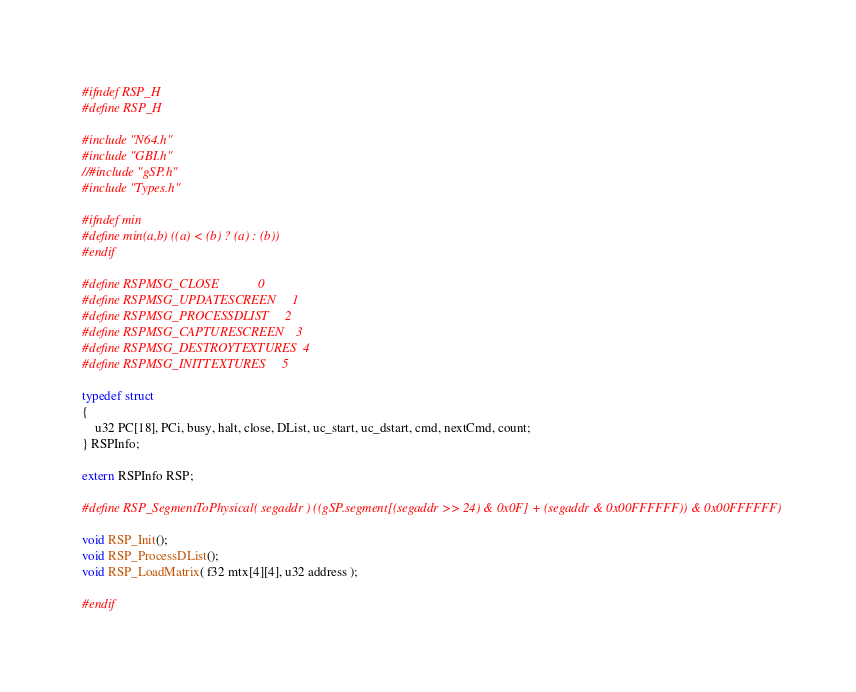Convert code to text. <code><loc_0><loc_0><loc_500><loc_500><_C_>#ifndef RSP_H
#define RSP_H

#include "N64.h"
#include "GBI.h"
//#include "gSP.h"
#include "Types.h"

#ifndef min
#define min(a,b) ((a) < (b) ? (a) : (b))
#endif

#define RSPMSG_CLOSE            0
#define RSPMSG_UPDATESCREEN     1
#define RSPMSG_PROCESSDLIST     2
#define RSPMSG_CAPTURESCREEN    3
#define RSPMSG_DESTROYTEXTURES  4
#define RSPMSG_INITTEXTURES     5

typedef struct
{
    u32 PC[18], PCi, busy, halt, close, DList, uc_start, uc_dstart, cmd, nextCmd, count;
} RSPInfo;

extern RSPInfo RSP;

#define RSP_SegmentToPhysical( segaddr ) ((gSP.segment[(segaddr >> 24) & 0x0F] + (segaddr & 0x00FFFFFF)) & 0x00FFFFFF)

void RSP_Init();
void RSP_ProcessDList();
void RSP_LoadMatrix( f32 mtx[4][4], u32 address );

#endif

</code> 